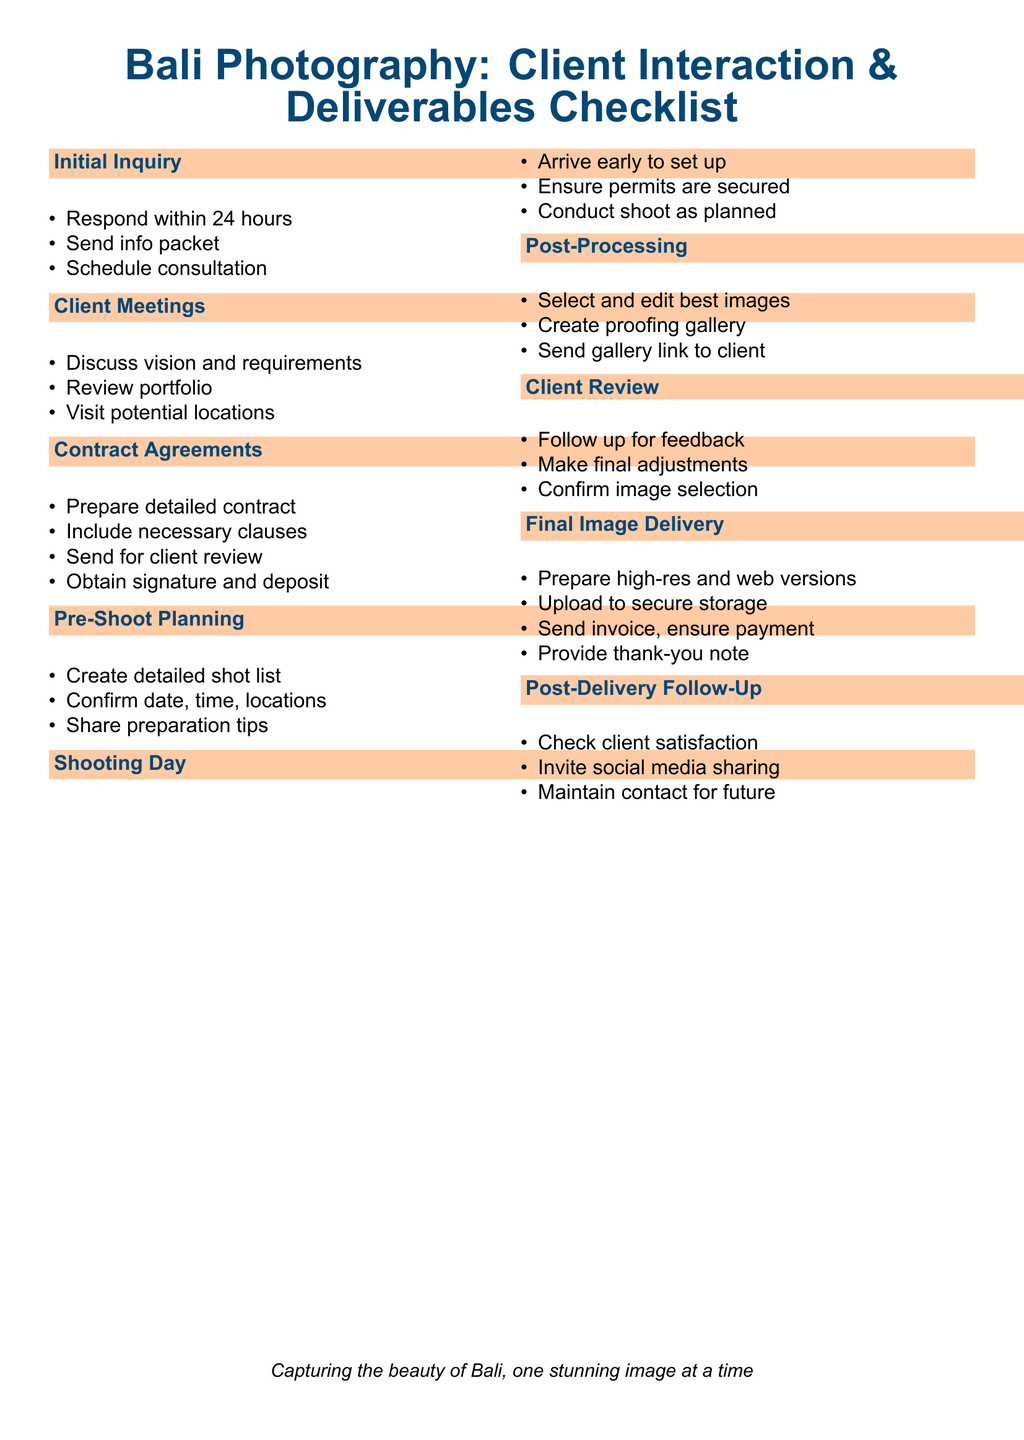What is the first step in the Initial Inquiry section? The first step listed under Initial Inquiry is to respond within 24 hours.
Answer: Respond within 24 hours How many items are listed under Client Meetings? There are three items detailed under Client Meetings.
Answer: Three What should be included in the contract according to Contract Agreements? The checklist specifies that necessary clauses should be included in the contract.
Answer: Necessary clauses What is sent to the client after creating the proofing gallery? After creating the proofing gallery, a gallery link is sent to the client.
Answer: Gallery link What follows the Client Review section? The section that follows Client Review is Final Image Delivery.
Answer: Final Image Delivery How is client satisfaction checked after delivery? Client satisfaction is checked through a follow-up.
Answer: Follow-up What item is included in the Final Image Delivery section before sending the invoice? Preparing high-res and web versions is the item listed before sending the invoice.
Answer: Prepare high-res and web versions Which section includes discussing vision and requirements? Discussing vision and requirements is covered under the Client Meetings section.
Answer: Client Meetings 